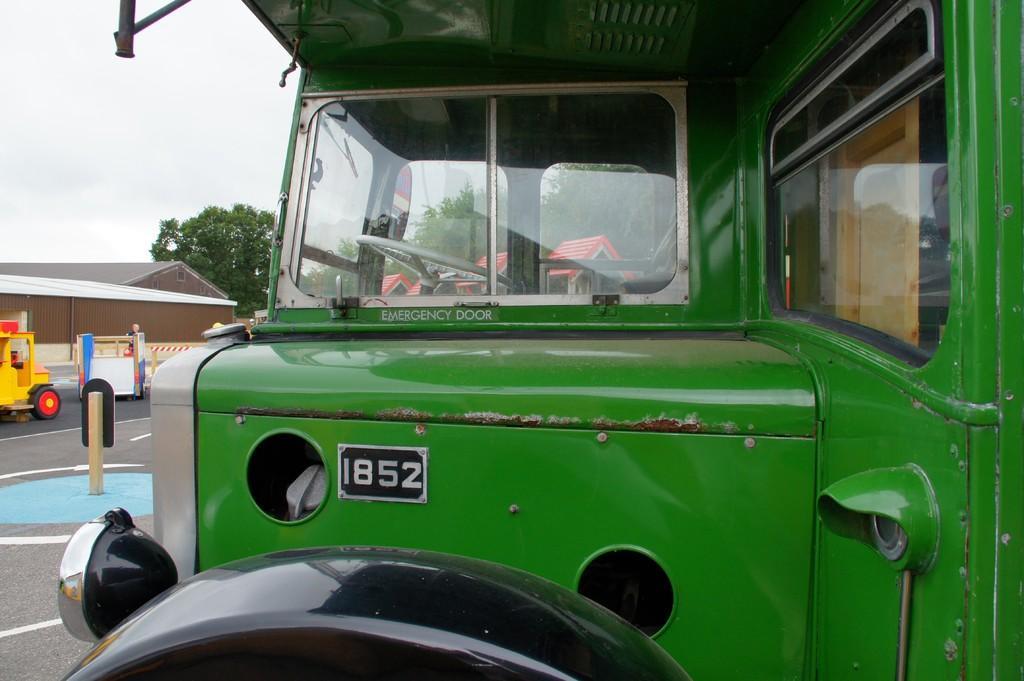Please provide a concise description of this image. In the center of the image we can see a truck on the left. There is a vehicle on the road and we can see a board. In the background there are sheds, trees and sky. 